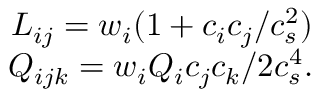Convert formula to latex. <formula><loc_0><loc_0><loc_500><loc_500>\begin{array} { r } { L _ { i j } = w _ { i } ( 1 + c _ { i } c _ { j } / c _ { s } ^ { 2 } ) } \\ { Q _ { i j k } = w _ { i } Q _ { i } c _ { j } c _ { k } / 2 c _ { s } ^ { 4 } . } \end{array}</formula> 